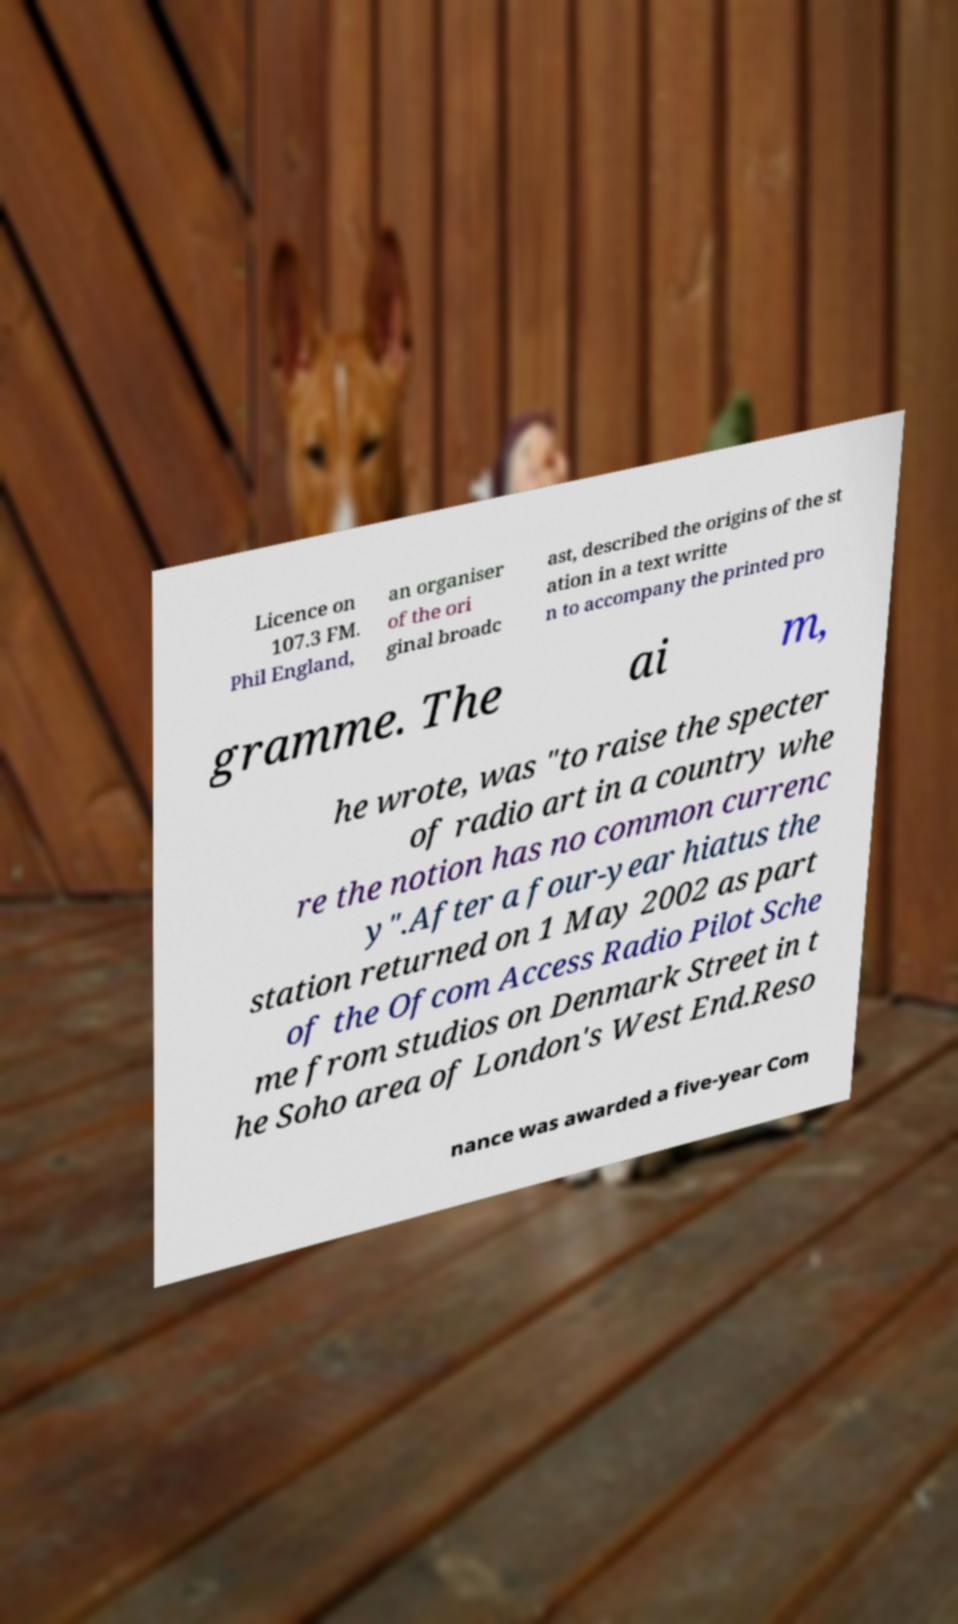For documentation purposes, I need the text within this image transcribed. Could you provide that? Licence on 107.3 FM. Phil England, an organiser of the ori ginal broadc ast, described the origins of the st ation in a text writte n to accompany the printed pro gramme. The ai m, he wrote, was "to raise the specter of radio art in a country whe re the notion has no common currenc y".After a four-year hiatus the station returned on 1 May 2002 as part of the Ofcom Access Radio Pilot Sche me from studios on Denmark Street in t he Soho area of London's West End.Reso nance was awarded a five-year Com 